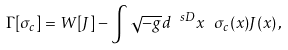<formula> <loc_0><loc_0><loc_500><loc_500>\Gamma [ \sigma _ { c } ] = W [ J ] - \int \sqrt { - g } d ^ { \ s D } x \ \sigma _ { c } ( x ) J ( x ) \, ,</formula> 